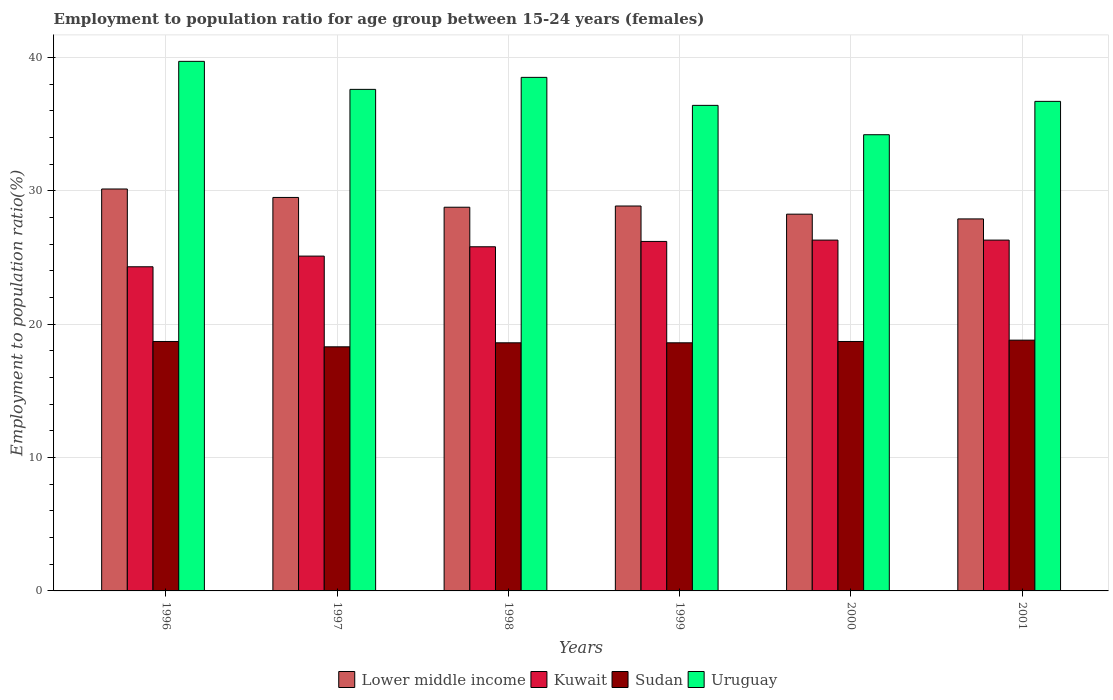How many different coloured bars are there?
Provide a short and direct response. 4. Are the number of bars per tick equal to the number of legend labels?
Ensure brevity in your answer.  Yes. Are the number of bars on each tick of the X-axis equal?
Provide a short and direct response. Yes. How many bars are there on the 1st tick from the left?
Provide a succinct answer. 4. How many bars are there on the 3rd tick from the right?
Provide a short and direct response. 4. What is the label of the 6th group of bars from the left?
Provide a succinct answer. 2001. In how many cases, is the number of bars for a given year not equal to the number of legend labels?
Your answer should be compact. 0. What is the employment to population ratio in Kuwait in 2000?
Your response must be concise. 26.3. Across all years, what is the maximum employment to population ratio in Kuwait?
Keep it short and to the point. 26.3. Across all years, what is the minimum employment to population ratio in Uruguay?
Provide a succinct answer. 34.2. In which year was the employment to population ratio in Sudan maximum?
Your answer should be compact. 2001. In which year was the employment to population ratio in Uruguay minimum?
Provide a short and direct response. 2000. What is the total employment to population ratio in Lower middle income in the graph?
Offer a terse response. 173.38. What is the difference between the employment to population ratio in Kuwait in 2000 and that in 2001?
Your response must be concise. 0. What is the difference between the employment to population ratio in Lower middle income in 1998 and the employment to population ratio in Kuwait in 2001?
Provide a short and direct response. 2.46. What is the average employment to population ratio in Lower middle income per year?
Your answer should be compact. 28.9. In the year 1998, what is the difference between the employment to population ratio in Kuwait and employment to population ratio in Uruguay?
Offer a very short reply. -12.7. In how many years, is the employment to population ratio in Uruguay greater than 20 %?
Your response must be concise. 6. What is the ratio of the employment to population ratio in Kuwait in 2000 to that in 2001?
Make the answer very short. 1. What is the difference between the highest and the lowest employment to population ratio in Lower middle income?
Your answer should be compact. 2.24. In how many years, is the employment to population ratio in Lower middle income greater than the average employment to population ratio in Lower middle income taken over all years?
Your answer should be very brief. 2. What does the 3rd bar from the left in 2001 represents?
Offer a very short reply. Sudan. What does the 3rd bar from the right in 1999 represents?
Give a very brief answer. Kuwait. Does the graph contain grids?
Give a very brief answer. Yes. Where does the legend appear in the graph?
Offer a very short reply. Bottom center. How many legend labels are there?
Offer a terse response. 4. How are the legend labels stacked?
Provide a succinct answer. Horizontal. What is the title of the graph?
Your response must be concise. Employment to population ratio for age group between 15-24 years (females). Does "Colombia" appear as one of the legend labels in the graph?
Your answer should be very brief. No. What is the Employment to population ratio(%) of Lower middle income in 1996?
Your answer should be very brief. 30.13. What is the Employment to population ratio(%) in Kuwait in 1996?
Offer a terse response. 24.3. What is the Employment to population ratio(%) in Sudan in 1996?
Offer a very short reply. 18.7. What is the Employment to population ratio(%) in Uruguay in 1996?
Ensure brevity in your answer.  39.7. What is the Employment to population ratio(%) in Lower middle income in 1997?
Your answer should be compact. 29.5. What is the Employment to population ratio(%) in Kuwait in 1997?
Keep it short and to the point. 25.1. What is the Employment to population ratio(%) in Sudan in 1997?
Provide a short and direct response. 18.3. What is the Employment to population ratio(%) in Uruguay in 1997?
Provide a short and direct response. 37.6. What is the Employment to population ratio(%) of Lower middle income in 1998?
Ensure brevity in your answer.  28.76. What is the Employment to population ratio(%) in Kuwait in 1998?
Provide a short and direct response. 25.8. What is the Employment to population ratio(%) in Sudan in 1998?
Keep it short and to the point. 18.6. What is the Employment to population ratio(%) of Uruguay in 1998?
Keep it short and to the point. 38.5. What is the Employment to population ratio(%) of Lower middle income in 1999?
Offer a terse response. 28.86. What is the Employment to population ratio(%) of Kuwait in 1999?
Give a very brief answer. 26.2. What is the Employment to population ratio(%) in Sudan in 1999?
Ensure brevity in your answer.  18.6. What is the Employment to population ratio(%) in Uruguay in 1999?
Provide a succinct answer. 36.4. What is the Employment to population ratio(%) in Lower middle income in 2000?
Offer a very short reply. 28.24. What is the Employment to population ratio(%) of Kuwait in 2000?
Offer a terse response. 26.3. What is the Employment to population ratio(%) of Sudan in 2000?
Keep it short and to the point. 18.7. What is the Employment to population ratio(%) in Uruguay in 2000?
Your response must be concise. 34.2. What is the Employment to population ratio(%) in Lower middle income in 2001?
Make the answer very short. 27.89. What is the Employment to population ratio(%) of Kuwait in 2001?
Make the answer very short. 26.3. What is the Employment to population ratio(%) in Sudan in 2001?
Your answer should be compact. 18.8. What is the Employment to population ratio(%) of Uruguay in 2001?
Provide a short and direct response. 36.7. Across all years, what is the maximum Employment to population ratio(%) of Lower middle income?
Your response must be concise. 30.13. Across all years, what is the maximum Employment to population ratio(%) in Kuwait?
Make the answer very short. 26.3. Across all years, what is the maximum Employment to population ratio(%) in Sudan?
Ensure brevity in your answer.  18.8. Across all years, what is the maximum Employment to population ratio(%) of Uruguay?
Give a very brief answer. 39.7. Across all years, what is the minimum Employment to population ratio(%) of Lower middle income?
Your answer should be compact. 27.89. Across all years, what is the minimum Employment to population ratio(%) of Kuwait?
Ensure brevity in your answer.  24.3. Across all years, what is the minimum Employment to population ratio(%) of Sudan?
Your answer should be compact. 18.3. Across all years, what is the minimum Employment to population ratio(%) of Uruguay?
Your answer should be compact. 34.2. What is the total Employment to population ratio(%) in Lower middle income in the graph?
Offer a very short reply. 173.38. What is the total Employment to population ratio(%) in Kuwait in the graph?
Offer a very short reply. 154. What is the total Employment to population ratio(%) in Sudan in the graph?
Offer a terse response. 111.7. What is the total Employment to population ratio(%) in Uruguay in the graph?
Make the answer very short. 223.1. What is the difference between the Employment to population ratio(%) of Lower middle income in 1996 and that in 1997?
Your response must be concise. 0.63. What is the difference between the Employment to population ratio(%) of Kuwait in 1996 and that in 1997?
Your answer should be very brief. -0.8. What is the difference between the Employment to population ratio(%) in Sudan in 1996 and that in 1997?
Make the answer very short. 0.4. What is the difference between the Employment to population ratio(%) in Uruguay in 1996 and that in 1997?
Provide a short and direct response. 2.1. What is the difference between the Employment to population ratio(%) in Lower middle income in 1996 and that in 1998?
Your answer should be very brief. 1.37. What is the difference between the Employment to population ratio(%) in Uruguay in 1996 and that in 1998?
Provide a succinct answer. 1.2. What is the difference between the Employment to population ratio(%) of Lower middle income in 1996 and that in 1999?
Ensure brevity in your answer.  1.27. What is the difference between the Employment to population ratio(%) in Uruguay in 1996 and that in 1999?
Your answer should be compact. 3.3. What is the difference between the Employment to population ratio(%) in Lower middle income in 1996 and that in 2000?
Provide a succinct answer. 1.89. What is the difference between the Employment to population ratio(%) of Kuwait in 1996 and that in 2000?
Your answer should be compact. -2. What is the difference between the Employment to population ratio(%) in Lower middle income in 1996 and that in 2001?
Give a very brief answer. 2.24. What is the difference between the Employment to population ratio(%) of Kuwait in 1996 and that in 2001?
Your answer should be very brief. -2. What is the difference between the Employment to population ratio(%) in Sudan in 1996 and that in 2001?
Provide a succinct answer. -0.1. What is the difference between the Employment to population ratio(%) of Lower middle income in 1997 and that in 1998?
Offer a terse response. 0.73. What is the difference between the Employment to population ratio(%) in Sudan in 1997 and that in 1998?
Ensure brevity in your answer.  -0.3. What is the difference between the Employment to population ratio(%) of Uruguay in 1997 and that in 1998?
Make the answer very short. -0.9. What is the difference between the Employment to population ratio(%) of Lower middle income in 1997 and that in 1999?
Your answer should be very brief. 0.64. What is the difference between the Employment to population ratio(%) in Uruguay in 1997 and that in 1999?
Your answer should be very brief. 1.2. What is the difference between the Employment to population ratio(%) of Lower middle income in 1997 and that in 2000?
Provide a succinct answer. 1.25. What is the difference between the Employment to population ratio(%) in Kuwait in 1997 and that in 2000?
Offer a terse response. -1.2. What is the difference between the Employment to population ratio(%) in Uruguay in 1997 and that in 2000?
Your answer should be compact. 3.4. What is the difference between the Employment to population ratio(%) of Lower middle income in 1997 and that in 2001?
Your response must be concise. 1.61. What is the difference between the Employment to population ratio(%) in Sudan in 1997 and that in 2001?
Keep it short and to the point. -0.5. What is the difference between the Employment to population ratio(%) in Lower middle income in 1998 and that in 1999?
Your response must be concise. -0.09. What is the difference between the Employment to population ratio(%) of Kuwait in 1998 and that in 1999?
Ensure brevity in your answer.  -0.4. What is the difference between the Employment to population ratio(%) in Sudan in 1998 and that in 1999?
Make the answer very short. 0. What is the difference between the Employment to population ratio(%) in Lower middle income in 1998 and that in 2000?
Make the answer very short. 0.52. What is the difference between the Employment to population ratio(%) in Uruguay in 1998 and that in 2000?
Provide a succinct answer. 4.3. What is the difference between the Employment to population ratio(%) of Lower middle income in 1998 and that in 2001?
Provide a short and direct response. 0.88. What is the difference between the Employment to population ratio(%) of Sudan in 1998 and that in 2001?
Give a very brief answer. -0.2. What is the difference between the Employment to population ratio(%) of Lower middle income in 1999 and that in 2000?
Offer a very short reply. 0.61. What is the difference between the Employment to population ratio(%) in Kuwait in 1999 and that in 2000?
Keep it short and to the point. -0.1. What is the difference between the Employment to population ratio(%) in Sudan in 1999 and that in 2000?
Offer a terse response. -0.1. What is the difference between the Employment to population ratio(%) in Uruguay in 1999 and that in 2000?
Keep it short and to the point. 2.2. What is the difference between the Employment to population ratio(%) of Kuwait in 1999 and that in 2001?
Provide a short and direct response. -0.1. What is the difference between the Employment to population ratio(%) in Uruguay in 1999 and that in 2001?
Make the answer very short. -0.3. What is the difference between the Employment to population ratio(%) in Lower middle income in 2000 and that in 2001?
Your response must be concise. 0.36. What is the difference between the Employment to population ratio(%) of Lower middle income in 1996 and the Employment to population ratio(%) of Kuwait in 1997?
Offer a very short reply. 5.03. What is the difference between the Employment to population ratio(%) in Lower middle income in 1996 and the Employment to population ratio(%) in Sudan in 1997?
Provide a succinct answer. 11.83. What is the difference between the Employment to population ratio(%) of Lower middle income in 1996 and the Employment to population ratio(%) of Uruguay in 1997?
Offer a very short reply. -7.47. What is the difference between the Employment to population ratio(%) of Kuwait in 1996 and the Employment to population ratio(%) of Uruguay in 1997?
Give a very brief answer. -13.3. What is the difference between the Employment to population ratio(%) in Sudan in 1996 and the Employment to population ratio(%) in Uruguay in 1997?
Your answer should be compact. -18.9. What is the difference between the Employment to population ratio(%) in Lower middle income in 1996 and the Employment to population ratio(%) in Kuwait in 1998?
Provide a short and direct response. 4.33. What is the difference between the Employment to population ratio(%) in Lower middle income in 1996 and the Employment to population ratio(%) in Sudan in 1998?
Offer a terse response. 11.53. What is the difference between the Employment to population ratio(%) in Lower middle income in 1996 and the Employment to population ratio(%) in Uruguay in 1998?
Provide a short and direct response. -8.37. What is the difference between the Employment to population ratio(%) of Kuwait in 1996 and the Employment to population ratio(%) of Uruguay in 1998?
Provide a succinct answer. -14.2. What is the difference between the Employment to population ratio(%) in Sudan in 1996 and the Employment to population ratio(%) in Uruguay in 1998?
Make the answer very short. -19.8. What is the difference between the Employment to population ratio(%) in Lower middle income in 1996 and the Employment to population ratio(%) in Kuwait in 1999?
Your answer should be compact. 3.93. What is the difference between the Employment to population ratio(%) of Lower middle income in 1996 and the Employment to population ratio(%) of Sudan in 1999?
Make the answer very short. 11.53. What is the difference between the Employment to population ratio(%) of Lower middle income in 1996 and the Employment to population ratio(%) of Uruguay in 1999?
Provide a short and direct response. -6.27. What is the difference between the Employment to population ratio(%) in Sudan in 1996 and the Employment to population ratio(%) in Uruguay in 1999?
Provide a short and direct response. -17.7. What is the difference between the Employment to population ratio(%) of Lower middle income in 1996 and the Employment to population ratio(%) of Kuwait in 2000?
Make the answer very short. 3.83. What is the difference between the Employment to population ratio(%) in Lower middle income in 1996 and the Employment to population ratio(%) in Sudan in 2000?
Ensure brevity in your answer.  11.43. What is the difference between the Employment to population ratio(%) of Lower middle income in 1996 and the Employment to population ratio(%) of Uruguay in 2000?
Your response must be concise. -4.07. What is the difference between the Employment to population ratio(%) in Kuwait in 1996 and the Employment to population ratio(%) in Sudan in 2000?
Make the answer very short. 5.6. What is the difference between the Employment to population ratio(%) in Sudan in 1996 and the Employment to population ratio(%) in Uruguay in 2000?
Offer a terse response. -15.5. What is the difference between the Employment to population ratio(%) of Lower middle income in 1996 and the Employment to population ratio(%) of Kuwait in 2001?
Offer a very short reply. 3.83. What is the difference between the Employment to population ratio(%) in Lower middle income in 1996 and the Employment to population ratio(%) in Sudan in 2001?
Provide a succinct answer. 11.33. What is the difference between the Employment to population ratio(%) in Lower middle income in 1996 and the Employment to population ratio(%) in Uruguay in 2001?
Provide a short and direct response. -6.57. What is the difference between the Employment to population ratio(%) of Kuwait in 1996 and the Employment to population ratio(%) of Sudan in 2001?
Offer a very short reply. 5.5. What is the difference between the Employment to population ratio(%) in Lower middle income in 1997 and the Employment to population ratio(%) in Kuwait in 1998?
Give a very brief answer. 3.7. What is the difference between the Employment to population ratio(%) of Lower middle income in 1997 and the Employment to population ratio(%) of Sudan in 1998?
Offer a terse response. 10.9. What is the difference between the Employment to population ratio(%) of Lower middle income in 1997 and the Employment to population ratio(%) of Uruguay in 1998?
Make the answer very short. -9. What is the difference between the Employment to population ratio(%) in Sudan in 1997 and the Employment to population ratio(%) in Uruguay in 1998?
Make the answer very short. -20.2. What is the difference between the Employment to population ratio(%) of Lower middle income in 1997 and the Employment to population ratio(%) of Kuwait in 1999?
Your answer should be compact. 3.3. What is the difference between the Employment to population ratio(%) of Lower middle income in 1997 and the Employment to population ratio(%) of Sudan in 1999?
Provide a succinct answer. 10.9. What is the difference between the Employment to population ratio(%) in Lower middle income in 1997 and the Employment to population ratio(%) in Uruguay in 1999?
Keep it short and to the point. -6.9. What is the difference between the Employment to population ratio(%) of Kuwait in 1997 and the Employment to population ratio(%) of Sudan in 1999?
Make the answer very short. 6.5. What is the difference between the Employment to population ratio(%) of Sudan in 1997 and the Employment to population ratio(%) of Uruguay in 1999?
Your response must be concise. -18.1. What is the difference between the Employment to population ratio(%) in Lower middle income in 1997 and the Employment to population ratio(%) in Kuwait in 2000?
Your answer should be very brief. 3.2. What is the difference between the Employment to population ratio(%) of Lower middle income in 1997 and the Employment to population ratio(%) of Sudan in 2000?
Provide a short and direct response. 10.8. What is the difference between the Employment to population ratio(%) in Lower middle income in 1997 and the Employment to population ratio(%) in Uruguay in 2000?
Offer a terse response. -4.7. What is the difference between the Employment to population ratio(%) of Sudan in 1997 and the Employment to population ratio(%) of Uruguay in 2000?
Your answer should be very brief. -15.9. What is the difference between the Employment to population ratio(%) in Lower middle income in 1997 and the Employment to population ratio(%) in Kuwait in 2001?
Your response must be concise. 3.2. What is the difference between the Employment to population ratio(%) in Lower middle income in 1997 and the Employment to population ratio(%) in Sudan in 2001?
Ensure brevity in your answer.  10.7. What is the difference between the Employment to population ratio(%) of Lower middle income in 1997 and the Employment to population ratio(%) of Uruguay in 2001?
Make the answer very short. -7.2. What is the difference between the Employment to population ratio(%) of Kuwait in 1997 and the Employment to population ratio(%) of Uruguay in 2001?
Give a very brief answer. -11.6. What is the difference between the Employment to population ratio(%) of Sudan in 1997 and the Employment to population ratio(%) of Uruguay in 2001?
Provide a succinct answer. -18.4. What is the difference between the Employment to population ratio(%) in Lower middle income in 1998 and the Employment to population ratio(%) in Kuwait in 1999?
Your response must be concise. 2.56. What is the difference between the Employment to population ratio(%) of Lower middle income in 1998 and the Employment to population ratio(%) of Sudan in 1999?
Provide a succinct answer. 10.16. What is the difference between the Employment to population ratio(%) of Lower middle income in 1998 and the Employment to population ratio(%) of Uruguay in 1999?
Your answer should be very brief. -7.64. What is the difference between the Employment to population ratio(%) of Kuwait in 1998 and the Employment to population ratio(%) of Sudan in 1999?
Keep it short and to the point. 7.2. What is the difference between the Employment to population ratio(%) of Sudan in 1998 and the Employment to population ratio(%) of Uruguay in 1999?
Give a very brief answer. -17.8. What is the difference between the Employment to population ratio(%) in Lower middle income in 1998 and the Employment to population ratio(%) in Kuwait in 2000?
Your response must be concise. 2.46. What is the difference between the Employment to population ratio(%) of Lower middle income in 1998 and the Employment to population ratio(%) of Sudan in 2000?
Give a very brief answer. 10.06. What is the difference between the Employment to population ratio(%) in Lower middle income in 1998 and the Employment to population ratio(%) in Uruguay in 2000?
Provide a succinct answer. -5.44. What is the difference between the Employment to population ratio(%) of Kuwait in 1998 and the Employment to population ratio(%) of Sudan in 2000?
Your answer should be very brief. 7.1. What is the difference between the Employment to population ratio(%) of Kuwait in 1998 and the Employment to population ratio(%) of Uruguay in 2000?
Keep it short and to the point. -8.4. What is the difference between the Employment to population ratio(%) in Sudan in 1998 and the Employment to population ratio(%) in Uruguay in 2000?
Your answer should be very brief. -15.6. What is the difference between the Employment to population ratio(%) in Lower middle income in 1998 and the Employment to population ratio(%) in Kuwait in 2001?
Your response must be concise. 2.46. What is the difference between the Employment to population ratio(%) in Lower middle income in 1998 and the Employment to population ratio(%) in Sudan in 2001?
Make the answer very short. 9.96. What is the difference between the Employment to population ratio(%) of Lower middle income in 1998 and the Employment to population ratio(%) of Uruguay in 2001?
Ensure brevity in your answer.  -7.94. What is the difference between the Employment to population ratio(%) in Kuwait in 1998 and the Employment to population ratio(%) in Sudan in 2001?
Your answer should be very brief. 7. What is the difference between the Employment to population ratio(%) of Kuwait in 1998 and the Employment to population ratio(%) of Uruguay in 2001?
Ensure brevity in your answer.  -10.9. What is the difference between the Employment to population ratio(%) in Sudan in 1998 and the Employment to population ratio(%) in Uruguay in 2001?
Your response must be concise. -18.1. What is the difference between the Employment to population ratio(%) of Lower middle income in 1999 and the Employment to population ratio(%) of Kuwait in 2000?
Provide a succinct answer. 2.56. What is the difference between the Employment to population ratio(%) in Lower middle income in 1999 and the Employment to population ratio(%) in Sudan in 2000?
Your response must be concise. 10.16. What is the difference between the Employment to population ratio(%) in Lower middle income in 1999 and the Employment to population ratio(%) in Uruguay in 2000?
Your answer should be very brief. -5.34. What is the difference between the Employment to population ratio(%) in Kuwait in 1999 and the Employment to population ratio(%) in Uruguay in 2000?
Your response must be concise. -8. What is the difference between the Employment to population ratio(%) of Sudan in 1999 and the Employment to population ratio(%) of Uruguay in 2000?
Your answer should be very brief. -15.6. What is the difference between the Employment to population ratio(%) of Lower middle income in 1999 and the Employment to population ratio(%) of Kuwait in 2001?
Offer a very short reply. 2.56. What is the difference between the Employment to population ratio(%) of Lower middle income in 1999 and the Employment to population ratio(%) of Sudan in 2001?
Your response must be concise. 10.06. What is the difference between the Employment to population ratio(%) in Lower middle income in 1999 and the Employment to population ratio(%) in Uruguay in 2001?
Your response must be concise. -7.84. What is the difference between the Employment to population ratio(%) in Kuwait in 1999 and the Employment to population ratio(%) in Sudan in 2001?
Give a very brief answer. 7.4. What is the difference between the Employment to population ratio(%) of Kuwait in 1999 and the Employment to population ratio(%) of Uruguay in 2001?
Make the answer very short. -10.5. What is the difference between the Employment to population ratio(%) in Sudan in 1999 and the Employment to population ratio(%) in Uruguay in 2001?
Ensure brevity in your answer.  -18.1. What is the difference between the Employment to population ratio(%) in Lower middle income in 2000 and the Employment to population ratio(%) in Kuwait in 2001?
Provide a short and direct response. 1.94. What is the difference between the Employment to population ratio(%) of Lower middle income in 2000 and the Employment to population ratio(%) of Sudan in 2001?
Offer a very short reply. 9.44. What is the difference between the Employment to population ratio(%) in Lower middle income in 2000 and the Employment to population ratio(%) in Uruguay in 2001?
Ensure brevity in your answer.  -8.46. What is the difference between the Employment to population ratio(%) in Kuwait in 2000 and the Employment to population ratio(%) in Uruguay in 2001?
Offer a very short reply. -10.4. What is the difference between the Employment to population ratio(%) of Sudan in 2000 and the Employment to population ratio(%) of Uruguay in 2001?
Offer a terse response. -18. What is the average Employment to population ratio(%) of Lower middle income per year?
Offer a terse response. 28.9. What is the average Employment to population ratio(%) of Kuwait per year?
Your answer should be very brief. 25.67. What is the average Employment to population ratio(%) in Sudan per year?
Offer a terse response. 18.62. What is the average Employment to population ratio(%) of Uruguay per year?
Your answer should be compact. 37.18. In the year 1996, what is the difference between the Employment to population ratio(%) of Lower middle income and Employment to population ratio(%) of Kuwait?
Provide a short and direct response. 5.83. In the year 1996, what is the difference between the Employment to population ratio(%) in Lower middle income and Employment to population ratio(%) in Sudan?
Ensure brevity in your answer.  11.43. In the year 1996, what is the difference between the Employment to population ratio(%) in Lower middle income and Employment to population ratio(%) in Uruguay?
Provide a succinct answer. -9.57. In the year 1996, what is the difference between the Employment to population ratio(%) of Kuwait and Employment to population ratio(%) of Sudan?
Offer a terse response. 5.6. In the year 1996, what is the difference between the Employment to population ratio(%) in Kuwait and Employment to population ratio(%) in Uruguay?
Make the answer very short. -15.4. In the year 1996, what is the difference between the Employment to population ratio(%) in Sudan and Employment to population ratio(%) in Uruguay?
Keep it short and to the point. -21. In the year 1997, what is the difference between the Employment to population ratio(%) of Lower middle income and Employment to population ratio(%) of Kuwait?
Make the answer very short. 4.4. In the year 1997, what is the difference between the Employment to population ratio(%) in Lower middle income and Employment to population ratio(%) in Sudan?
Your answer should be very brief. 11.2. In the year 1997, what is the difference between the Employment to population ratio(%) in Lower middle income and Employment to population ratio(%) in Uruguay?
Offer a terse response. -8.1. In the year 1997, what is the difference between the Employment to population ratio(%) of Kuwait and Employment to population ratio(%) of Sudan?
Provide a succinct answer. 6.8. In the year 1997, what is the difference between the Employment to population ratio(%) of Kuwait and Employment to population ratio(%) of Uruguay?
Offer a terse response. -12.5. In the year 1997, what is the difference between the Employment to population ratio(%) of Sudan and Employment to population ratio(%) of Uruguay?
Provide a succinct answer. -19.3. In the year 1998, what is the difference between the Employment to population ratio(%) in Lower middle income and Employment to population ratio(%) in Kuwait?
Ensure brevity in your answer.  2.96. In the year 1998, what is the difference between the Employment to population ratio(%) of Lower middle income and Employment to population ratio(%) of Sudan?
Provide a short and direct response. 10.16. In the year 1998, what is the difference between the Employment to population ratio(%) of Lower middle income and Employment to population ratio(%) of Uruguay?
Offer a terse response. -9.74. In the year 1998, what is the difference between the Employment to population ratio(%) in Kuwait and Employment to population ratio(%) in Sudan?
Your answer should be very brief. 7.2. In the year 1998, what is the difference between the Employment to population ratio(%) of Kuwait and Employment to population ratio(%) of Uruguay?
Ensure brevity in your answer.  -12.7. In the year 1998, what is the difference between the Employment to population ratio(%) in Sudan and Employment to population ratio(%) in Uruguay?
Give a very brief answer. -19.9. In the year 1999, what is the difference between the Employment to population ratio(%) in Lower middle income and Employment to population ratio(%) in Kuwait?
Offer a very short reply. 2.66. In the year 1999, what is the difference between the Employment to population ratio(%) of Lower middle income and Employment to population ratio(%) of Sudan?
Give a very brief answer. 10.26. In the year 1999, what is the difference between the Employment to population ratio(%) of Lower middle income and Employment to population ratio(%) of Uruguay?
Your answer should be very brief. -7.54. In the year 1999, what is the difference between the Employment to population ratio(%) of Kuwait and Employment to population ratio(%) of Sudan?
Ensure brevity in your answer.  7.6. In the year 1999, what is the difference between the Employment to population ratio(%) in Kuwait and Employment to population ratio(%) in Uruguay?
Provide a succinct answer. -10.2. In the year 1999, what is the difference between the Employment to population ratio(%) of Sudan and Employment to population ratio(%) of Uruguay?
Provide a short and direct response. -17.8. In the year 2000, what is the difference between the Employment to population ratio(%) of Lower middle income and Employment to population ratio(%) of Kuwait?
Make the answer very short. 1.94. In the year 2000, what is the difference between the Employment to population ratio(%) in Lower middle income and Employment to population ratio(%) in Sudan?
Ensure brevity in your answer.  9.54. In the year 2000, what is the difference between the Employment to population ratio(%) in Lower middle income and Employment to population ratio(%) in Uruguay?
Make the answer very short. -5.96. In the year 2000, what is the difference between the Employment to population ratio(%) in Kuwait and Employment to population ratio(%) in Sudan?
Make the answer very short. 7.6. In the year 2000, what is the difference between the Employment to population ratio(%) of Sudan and Employment to population ratio(%) of Uruguay?
Ensure brevity in your answer.  -15.5. In the year 2001, what is the difference between the Employment to population ratio(%) in Lower middle income and Employment to population ratio(%) in Kuwait?
Offer a terse response. 1.59. In the year 2001, what is the difference between the Employment to population ratio(%) of Lower middle income and Employment to population ratio(%) of Sudan?
Provide a short and direct response. 9.09. In the year 2001, what is the difference between the Employment to population ratio(%) of Lower middle income and Employment to population ratio(%) of Uruguay?
Keep it short and to the point. -8.81. In the year 2001, what is the difference between the Employment to population ratio(%) in Kuwait and Employment to population ratio(%) in Sudan?
Your answer should be very brief. 7.5. In the year 2001, what is the difference between the Employment to population ratio(%) in Sudan and Employment to population ratio(%) in Uruguay?
Provide a succinct answer. -17.9. What is the ratio of the Employment to population ratio(%) of Lower middle income in 1996 to that in 1997?
Make the answer very short. 1.02. What is the ratio of the Employment to population ratio(%) in Kuwait in 1996 to that in 1997?
Give a very brief answer. 0.97. What is the ratio of the Employment to population ratio(%) of Sudan in 1996 to that in 1997?
Offer a very short reply. 1.02. What is the ratio of the Employment to population ratio(%) of Uruguay in 1996 to that in 1997?
Keep it short and to the point. 1.06. What is the ratio of the Employment to population ratio(%) in Lower middle income in 1996 to that in 1998?
Provide a succinct answer. 1.05. What is the ratio of the Employment to population ratio(%) in Kuwait in 1996 to that in 1998?
Keep it short and to the point. 0.94. What is the ratio of the Employment to population ratio(%) of Sudan in 1996 to that in 1998?
Give a very brief answer. 1.01. What is the ratio of the Employment to population ratio(%) in Uruguay in 1996 to that in 1998?
Your response must be concise. 1.03. What is the ratio of the Employment to population ratio(%) in Lower middle income in 1996 to that in 1999?
Your answer should be compact. 1.04. What is the ratio of the Employment to population ratio(%) of Kuwait in 1996 to that in 1999?
Keep it short and to the point. 0.93. What is the ratio of the Employment to population ratio(%) in Sudan in 1996 to that in 1999?
Make the answer very short. 1.01. What is the ratio of the Employment to population ratio(%) of Uruguay in 1996 to that in 1999?
Offer a terse response. 1.09. What is the ratio of the Employment to population ratio(%) in Lower middle income in 1996 to that in 2000?
Provide a short and direct response. 1.07. What is the ratio of the Employment to population ratio(%) in Kuwait in 1996 to that in 2000?
Offer a very short reply. 0.92. What is the ratio of the Employment to population ratio(%) of Sudan in 1996 to that in 2000?
Give a very brief answer. 1. What is the ratio of the Employment to population ratio(%) of Uruguay in 1996 to that in 2000?
Provide a short and direct response. 1.16. What is the ratio of the Employment to population ratio(%) of Lower middle income in 1996 to that in 2001?
Provide a succinct answer. 1.08. What is the ratio of the Employment to population ratio(%) in Kuwait in 1996 to that in 2001?
Provide a short and direct response. 0.92. What is the ratio of the Employment to population ratio(%) in Uruguay in 1996 to that in 2001?
Give a very brief answer. 1.08. What is the ratio of the Employment to population ratio(%) of Lower middle income in 1997 to that in 1998?
Provide a succinct answer. 1.03. What is the ratio of the Employment to population ratio(%) in Kuwait in 1997 to that in 1998?
Offer a very short reply. 0.97. What is the ratio of the Employment to population ratio(%) of Sudan in 1997 to that in 1998?
Keep it short and to the point. 0.98. What is the ratio of the Employment to population ratio(%) of Uruguay in 1997 to that in 1998?
Make the answer very short. 0.98. What is the ratio of the Employment to population ratio(%) in Lower middle income in 1997 to that in 1999?
Keep it short and to the point. 1.02. What is the ratio of the Employment to population ratio(%) of Kuwait in 1997 to that in 1999?
Keep it short and to the point. 0.96. What is the ratio of the Employment to population ratio(%) in Sudan in 1997 to that in 1999?
Your response must be concise. 0.98. What is the ratio of the Employment to population ratio(%) of Uruguay in 1997 to that in 1999?
Your response must be concise. 1.03. What is the ratio of the Employment to population ratio(%) of Lower middle income in 1997 to that in 2000?
Keep it short and to the point. 1.04. What is the ratio of the Employment to population ratio(%) of Kuwait in 1997 to that in 2000?
Offer a very short reply. 0.95. What is the ratio of the Employment to population ratio(%) in Sudan in 1997 to that in 2000?
Provide a succinct answer. 0.98. What is the ratio of the Employment to population ratio(%) of Uruguay in 1997 to that in 2000?
Your response must be concise. 1.1. What is the ratio of the Employment to population ratio(%) in Lower middle income in 1997 to that in 2001?
Give a very brief answer. 1.06. What is the ratio of the Employment to population ratio(%) in Kuwait in 1997 to that in 2001?
Your response must be concise. 0.95. What is the ratio of the Employment to population ratio(%) of Sudan in 1997 to that in 2001?
Your response must be concise. 0.97. What is the ratio of the Employment to population ratio(%) of Uruguay in 1997 to that in 2001?
Your answer should be compact. 1.02. What is the ratio of the Employment to population ratio(%) in Lower middle income in 1998 to that in 1999?
Make the answer very short. 1. What is the ratio of the Employment to population ratio(%) in Kuwait in 1998 to that in 1999?
Provide a short and direct response. 0.98. What is the ratio of the Employment to population ratio(%) in Sudan in 1998 to that in 1999?
Provide a succinct answer. 1. What is the ratio of the Employment to population ratio(%) of Uruguay in 1998 to that in 1999?
Keep it short and to the point. 1.06. What is the ratio of the Employment to population ratio(%) in Lower middle income in 1998 to that in 2000?
Your response must be concise. 1.02. What is the ratio of the Employment to population ratio(%) of Kuwait in 1998 to that in 2000?
Your answer should be very brief. 0.98. What is the ratio of the Employment to population ratio(%) of Uruguay in 1998 to that in 2000?
Give a very brief answer. 1.13. What is the ratio of the Employment to population ratio(%) of Lower middle income in 1998 to that in 2001?
Provide a succinct answer. 1.03. What is the ratio of the Employment to population ratio(%) in Kuwait in 1998 to that in 2001?
Give a very brief answer. 0.98. What is the ratio of the Employment to population ratio(%) of Uruguay in 1998 to that in 2001?
Keep it short and to the point. 1.05. What is the ratio of the Employment to population ratio(%) in Lower middle income in 1999 to that in 2000?
Offer a terse response. 1.02. What is the ratio of the Employment to population ratio(%) in Kuwait in 1999 to that in 2000?
Your response must be concise. 1. What is the ratio of the Employment to population ratio(%) in Uruguay in 1999 to that in 2000?
Your answer should be very brief. 1.06. What is the ratio of the Employment to population ratio(%) in Lower middle income in 1999 to that in 2001?
Keep it short and to the point. 1.03. What is the ratio of the Employment to population ratio(%) in Kuwait in 1999 to that in 2001?
Your answer should be very brief. 1. What is the ratio of the Employment to population ratio(%) of Sudan in 1999 to that in 2001?
Give a very brief answer. 0.99. What is the ratio of the Employment to population ratio(%) of Uruguay in 1999 to that in 2001?
Your answer should be compact. 0.99. What is the ratio of the Employment to population ratio(%) in Lower middle income in 2000 to that in 2001?
Provide a succinct answer. 1.01. What is the ratio of the Employment to population ratio(%) of Kuwait in 2000 to that in 2001?
Your answer should be very brief. 1. What is the ratio of the Employment to population ratio(%) in Uruguay in 2000 to that in 2001?
Your response must be concise. 0.93. What is the difference between the highest and the second highest Employment to population ratio(%) of Lower middle income?
Give a very brief answer. 0.63. What is the difference between the highest and the second highest Employment to population ratio(%) in Kuwait?
Your answer should be very brief. 0. What is the difference between the highest and the second highest Employment to population ratio(%) in Uruguay?
Your response must be concise. 1.2. What is the difference between the highest and the lowest Employment to population ratio(%) in Lower middle income?
Ensure brevity in your answer.  2.24. What is the difference between the highest and the lowest Employment to population ratio(%) of Sudan?
Provide a short and direct response. 0.5. What is the difference between the highest and the lowest Employment to population ratio(%) in Uruguay?
Give a very brief answer. 5.5. 